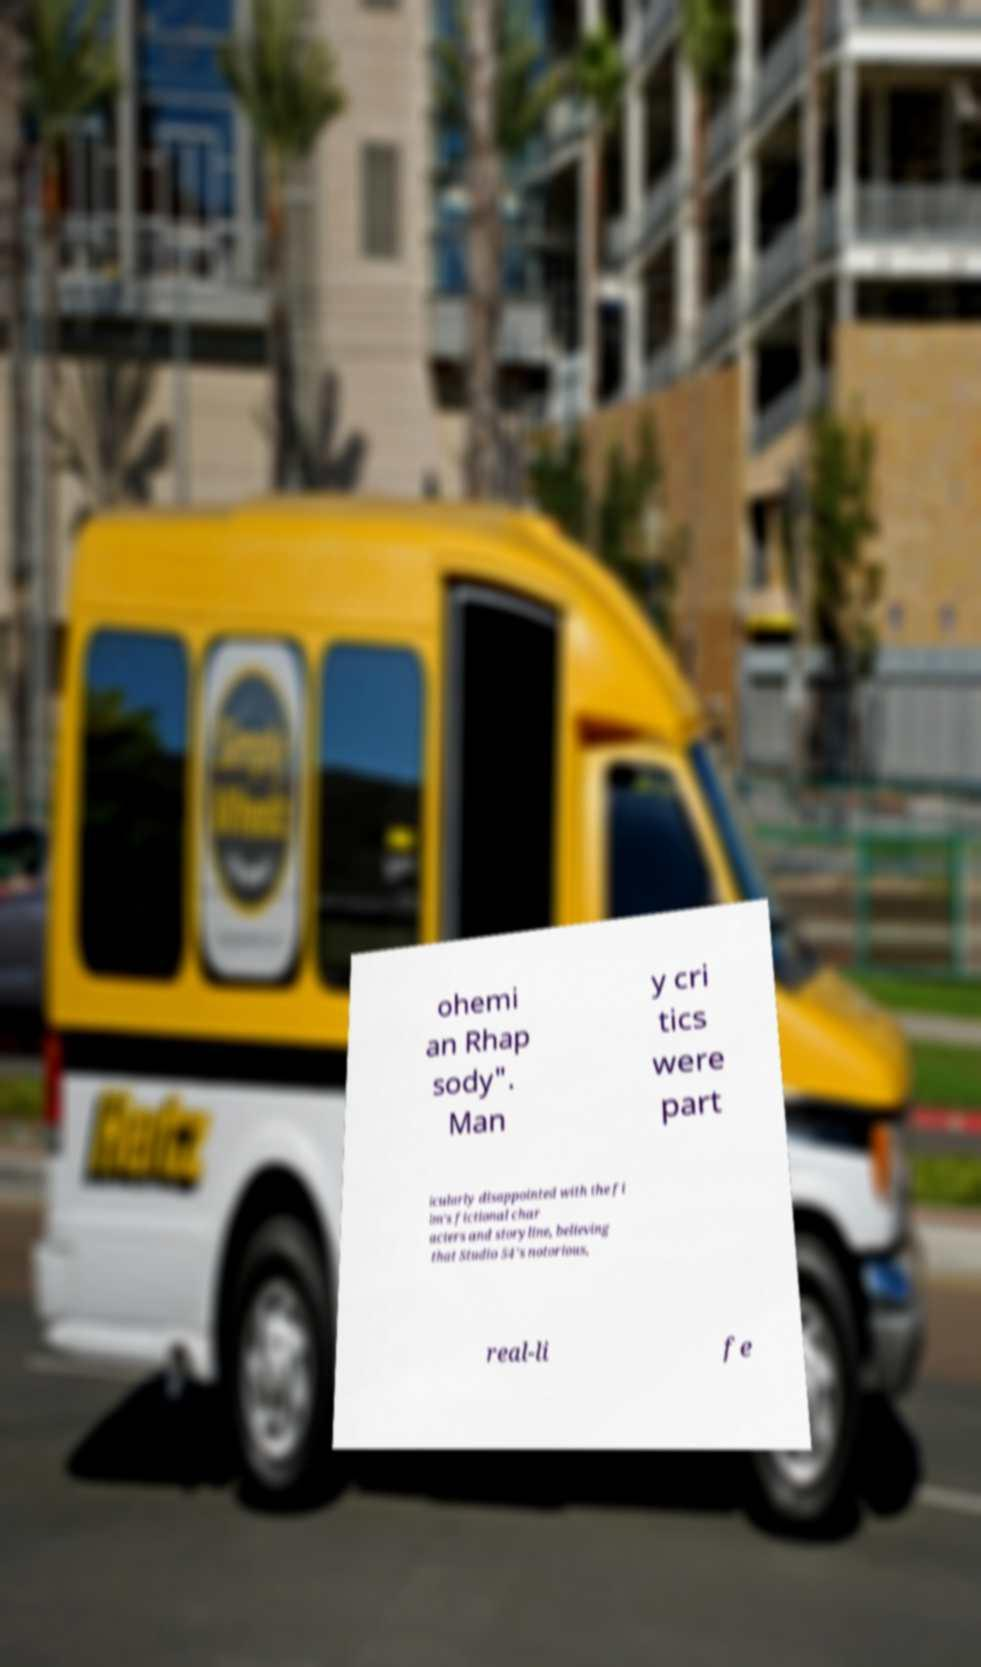Could you assist in decoding the text presented in this image and type it out clearly? ohemi an Rhap sody". Man y cri tics were part icularly disappointed with the fi lm's fictional char acters and storyline, believing that Studio 54's notorious, real-li fe 